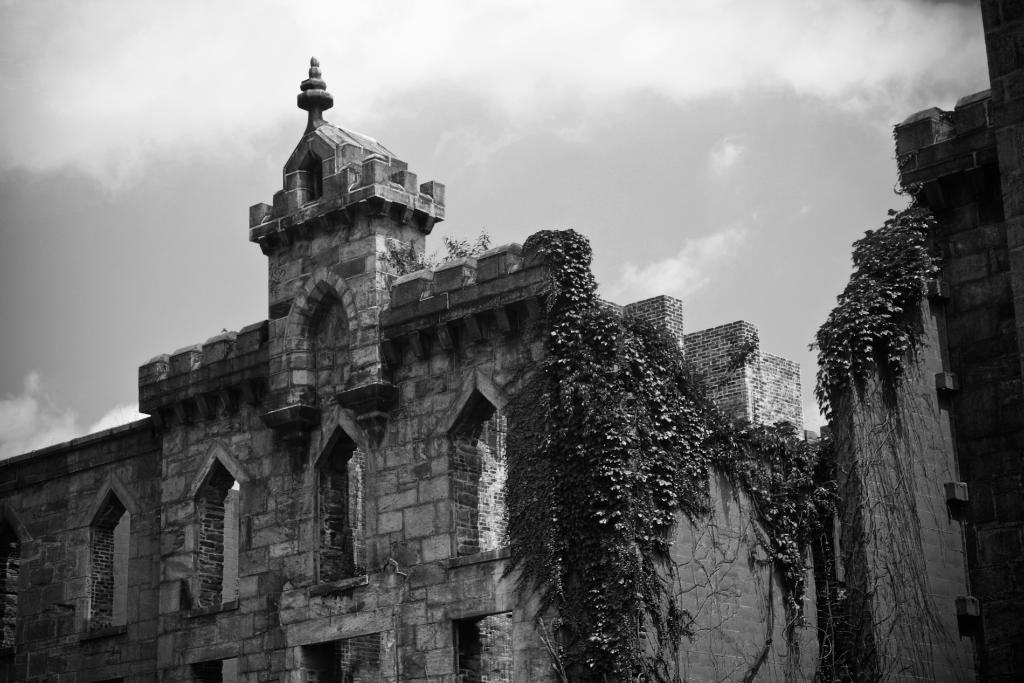What type of structures can be seen in the image? The image contains architecture. What type of vegetation is visible in the image? There are leaves visible in the image. What is the condition of the sky in the image? The sky is cloudy in the image. What type of mailbox can be seen in the image? There is no mailbox present in the image. What is the tax rate for the area depicted in the image? The image does not provide any information about tax rates. 